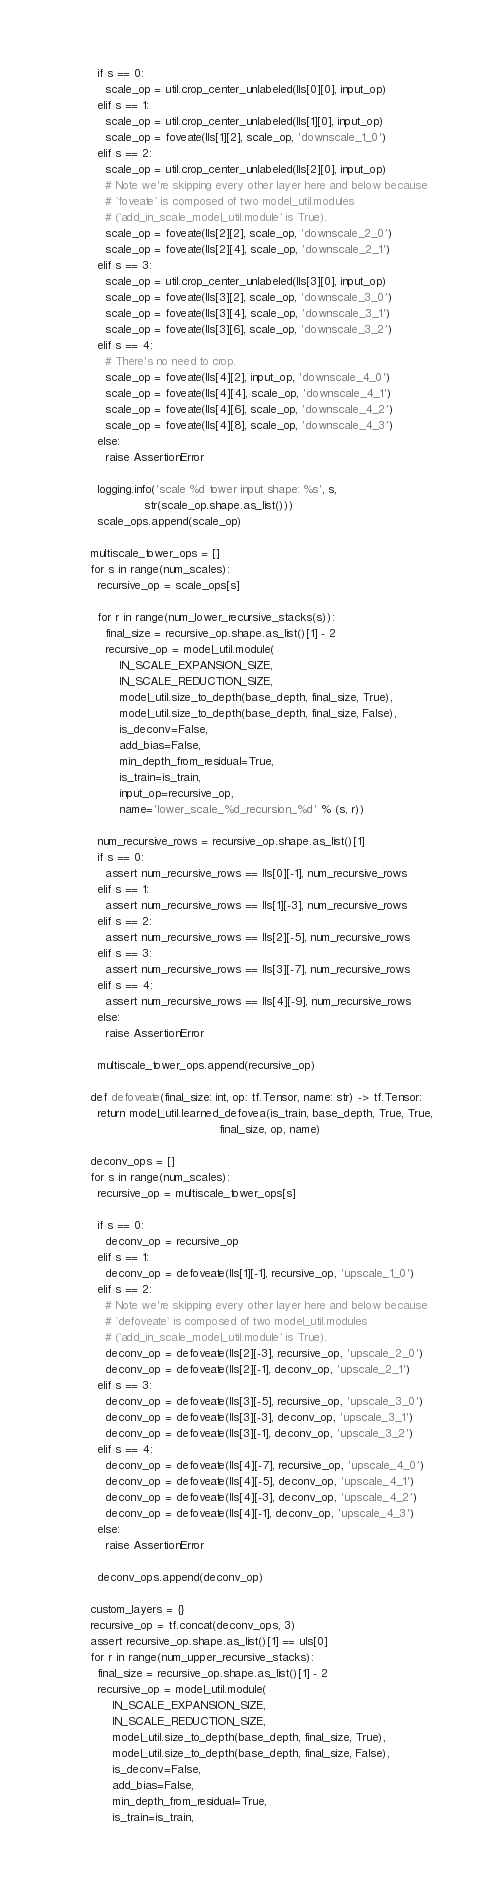<code> <loc_0><loc_0><loc_500><loc_500><_Python_>      if s == 0:
        scale_op = util.crop_center_unlabeled(lls[0][0], input_op)
      elif s == 1:
        scale_op = util.crop_center_unlabeled(lls[1][0], input_op)
        scale_op = foveate(lls[1][2], scale_op, 'downscale_1_0')
      elif s == 2:
        scale_op = util.crop_center_unlabeled(lls[2][0], input_op)
        # Note we're skipping every other layer here and below because
        # `foveate` is composed of two model_util.modules
        # (`add_in_scale_model_util.module` is True).
        scale_op = foveate(lls[2][2], scale_op, 'downscale_2_0')
        scale_op = foveate(lls[2][4], scale_op, 'downscale_2_1')
      elif s == 3:
        scale_op = util.crop_center_unlabeled(lls[3][0], input_op)
        scale_op = foveate(lls[3][2], scale_op, 'downscale_3_0')
        scale_op = foveate(lls[3][4], scale_op, 'downscale_3_1')
        scale_op = foveate(lls[3][6], scale_op, 'downscale_3_2')
      elif s == 4:
        # There's no need to crop.
        scale_op = foveate(lls[4][2], input_op, 'downscale_4_0')
        scale_op = foveate(lls[4][4], scale_op, 'downscale_4_1')
        scale_op = foveate(lls[4][6], scale_op, 'downscale_4_2')
        scale_op = foveate(lls[4][8], scale_op, 'downscale_4_3')
      else:
        raise AssertionError

      logging.info('scale %d tower input shape: %s', s,
                   str(scale_op.shape.as_list()))
      scale_ops.append(scale_op)

    multiscale_tower_ops = []
    for s in range(num_scales):
      recursive_op = scale_ops[s]

      for r in range(num_lower_recursive_stacks(s)):
        final_size = recursive_op.shape.as_list()[1] - 2
        recursive_op = model_util.module(
            IN_SCALE_EXPANSION_SIZE,
            IN_SCALE_REDUCTION_SIZE,
            model_util.size_to_depth(base_depth, final_size, True),
            model_util.size_to_depth(base_depth, final_size, False),
            is_deconv=False,
            add_bias=False,
            min_depth_from_residual=True,
            is_train=is_train,
            input_op=recursive_op,
            name='lower_scale_%d_recursion_%d' % (s, r))

      num_recursive_rows = recursive_op.shape.as_list()[1]
      if s == 0:
        assert num_recursive_rows == lls[0][-1], num_recursive_rows
      elif s == 1:
        assert num_recursive_rows == lls[1][-3], num_recursive_rows
      elif s == 2:
        assert num_recursive_rows == lls[2][-5], num_recursive_rows
      elif s == 3:
        assert num_recursive_rows == lls[3][-7], num_recursive_rows
      elif s == 4:
        assert num_recursive_rows == lls[4][-9], num_recursive_rows
      else:
        raise AssertionError

      multiscale_tower_ops.append(recursive_op)

    def defoveate(final_size: int, op: tf.Tensor, name: str) -> tf.Tensor:
      return model_util.learned_defovea(is_train, base_depth, True, True,
                                        final_size, op, name)

    deconv_ops = []
    for s in range(num_scales):
      recursive_op = multiscale_tower_ops[s]

      if s == 0:
        deconv_op = recursive_op
      elif s == 1:
        deconv_op = defoveate(lls[1][-1], recursive_op, 'upscale_1_0')
      elif s == 2:
        # Note we're skipping every other layer here and below because
        # `defoveate` is composed of two model_util.modules
        # (`add_in_scale_model_util.module` is True).
        deconv_op = defoveate(lls[2][-3], recursive_op, 'upscale_2_0')
        deconv_op = defoveate(lls[2][-1], deconv_op, 'upscale_2_1')
      elif s == 3:
        deconv_op = defoveate(lls[3][-5], recursive_op, 'upscale_3_0')
        deconv_op = defoveate(lls[3][-3], deconv_op, 'upscale_3_1')
        deconv_op = defoveate(lls[3][-1], deconv_op, 'upscale_3_2')
      elif s == 4:
        deconv_op = defoveate(lls[4][-7], recursive_op, 'upscale_4_0')
        deconv_op = defoveate(lls[4][-5], deconv_op, 'upscale_4_1')
        deconv_op = defoveate(lls[4][-3], deconv_op, 'upscale_4_2')
        deconv_op = defoveate(lls[4][-1], deconv_op, 'upscale_4_3')
      else:
        raise AssertionError

      deconv_ops.append(deconv_op)

    custom_layers = {}
    recursive_op = tf.concat(deconv_ops, 3)
    assert recursive_op.shape.as_list()[1] == uls[0]
    for r in range(num_upper_recursive_stacks):
      final_size = recursive_op.shape.as_list()[1] - 2
      recursive_op = model_util.module(
          IN_SCALE_EXPANSION_SIZE,
          IN_SCALE_REDUCTION_SIZE,
          model_util.size_to_depth(base_depth, final_size, True),
          model_util.size_to_depth(base_depth, final_size, False),
          is_deconv=False,
          add_bias=False,
          min_depth_from_residual=True,
          is_train=is_train,</code> 